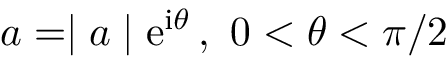<formula> <loc_0><loc_0><loc_500><loc_500>a = | a | e ^ { i \theta } \, , \, 0 < \theta < \pi / 2</formula> 